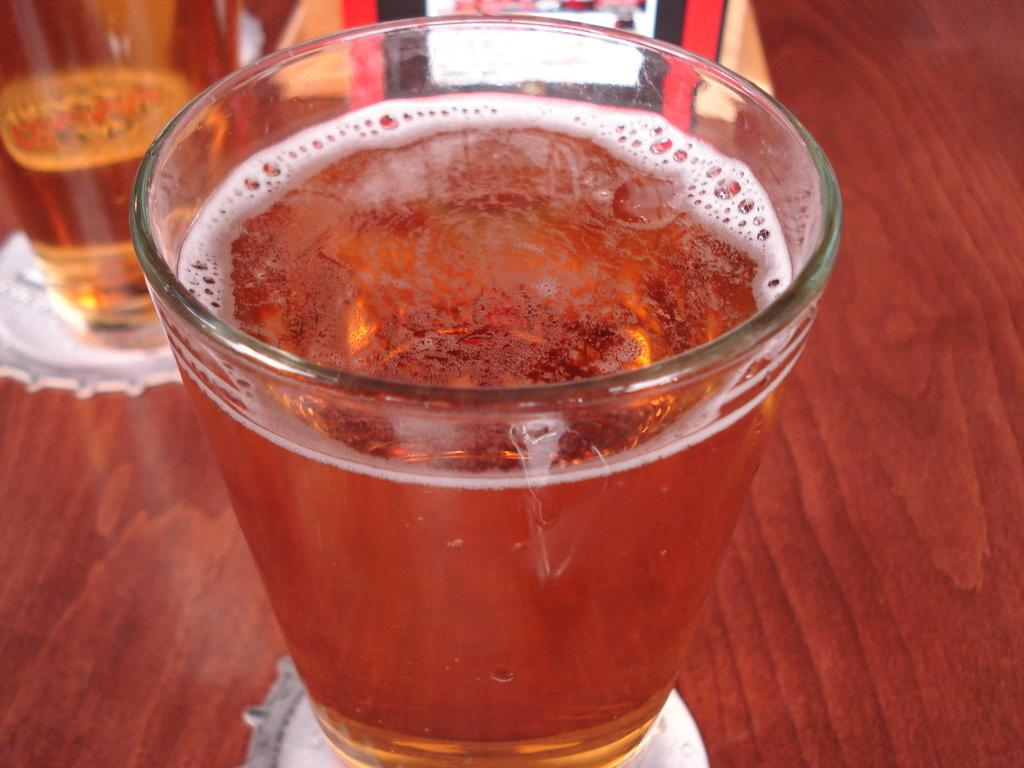What is in the glass that is visible in the image? There is a glass with liquid in the image. What is the color of the table that the glass is on? The table is brown-colored. How many glasses can be seen in the image? There are two glasses in the image. What other objects are present on the table? There are other objects on the table, but their specific details are not mentioned in the provided facts. What type of sand can be seen on the table in the image? There is no sand present on the table in the image. How many sticks are visible on the table in the image? There is no mention of sticks in the provided facts, so we cannot determine their presence or quantity in the image. 